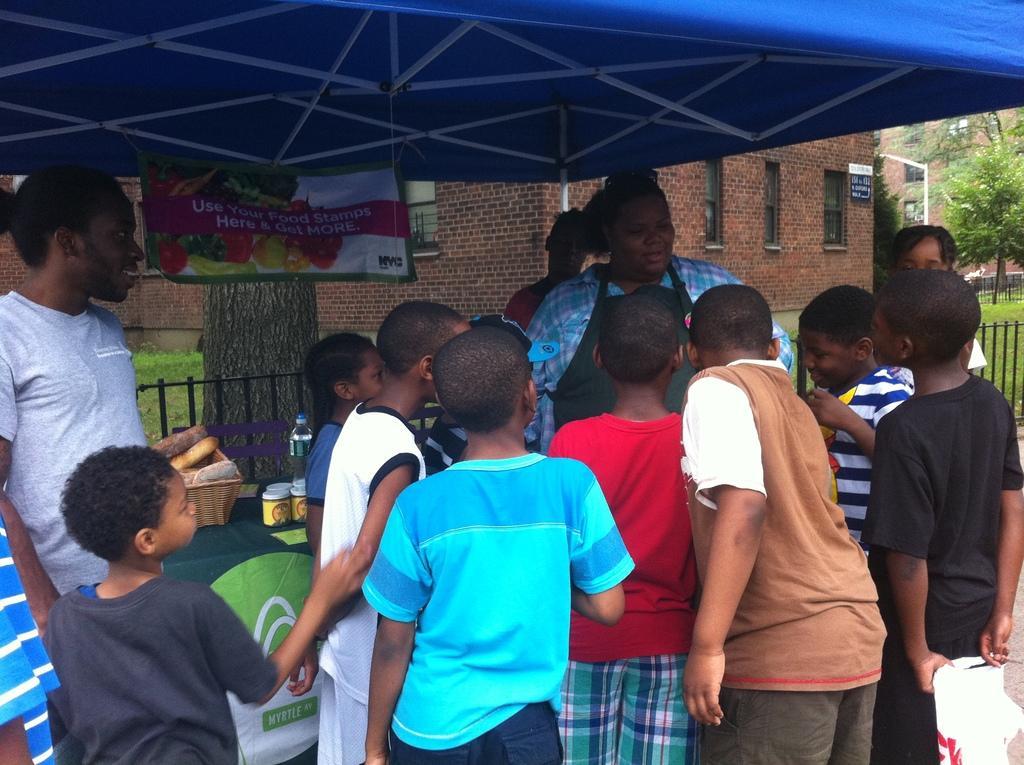Describe this image in one or two sentences. In the foreground of this picture, there are boys standing and surrounding a woman. In the background, there is a man standing, a table on which baskets, containers and bottles on it. We can also see a banner to the shed, trees, buildings, railing and the grass in the background. 